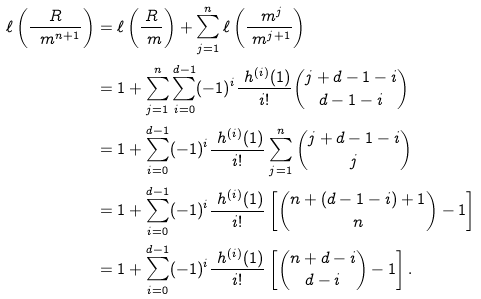Convert formula to latex. <formula><loc_0><loc_0><loc_500><loc_500>\ell \left ( \frac { R } { \ m ^ { n + 1 } } \right ) & = \ell \left ( \frac { R } { \ m } \right ) + \sum _ { j = 1 } ^ { n } \ell \left ( \frac { \ m ^ { j } } { \ m ^ { j + 1 } } \right ) \\ & = 1 + \sum _ { j = 1 } ^ { n } \sum _ { i = 0 } ^ { d - 1 } ( - 1 ) ^ { i } \frac { \ h ^ { ( i ) } ( 1 ) } { i ! } { j + d - 1 - i \choose d - 1 - i } \\ & = 1 + \sum _ { i = 0 } ^ { d - 1 } ( - 1 ) ^ { i } \frac { \ h ^ { ( i ) } ( 1 ) } { i ! } \sum _ { j = 1 } ^ { n } { j + d - 1 - i \choose j } \\ & = 1 + \sum _ { i = 0 } ^ { d - 1 } ( - 1 ) ^ { i } \frac { \ h ^ { ( i ) } ( 1 ) } { i ! } \left [ { n + ( d - 1 - i ) + 1 \choose n } - 1 \right ] \\ & = 1 + \sum _ { i = 0 } ^ { d - 1 } ( - 1 ) ^ { i } \frac { \ h ^ { ( i ) } ( 1 ) } { i ! } \left [ { n + d - i \choose d - i } - 1 \right ] .</formula> 